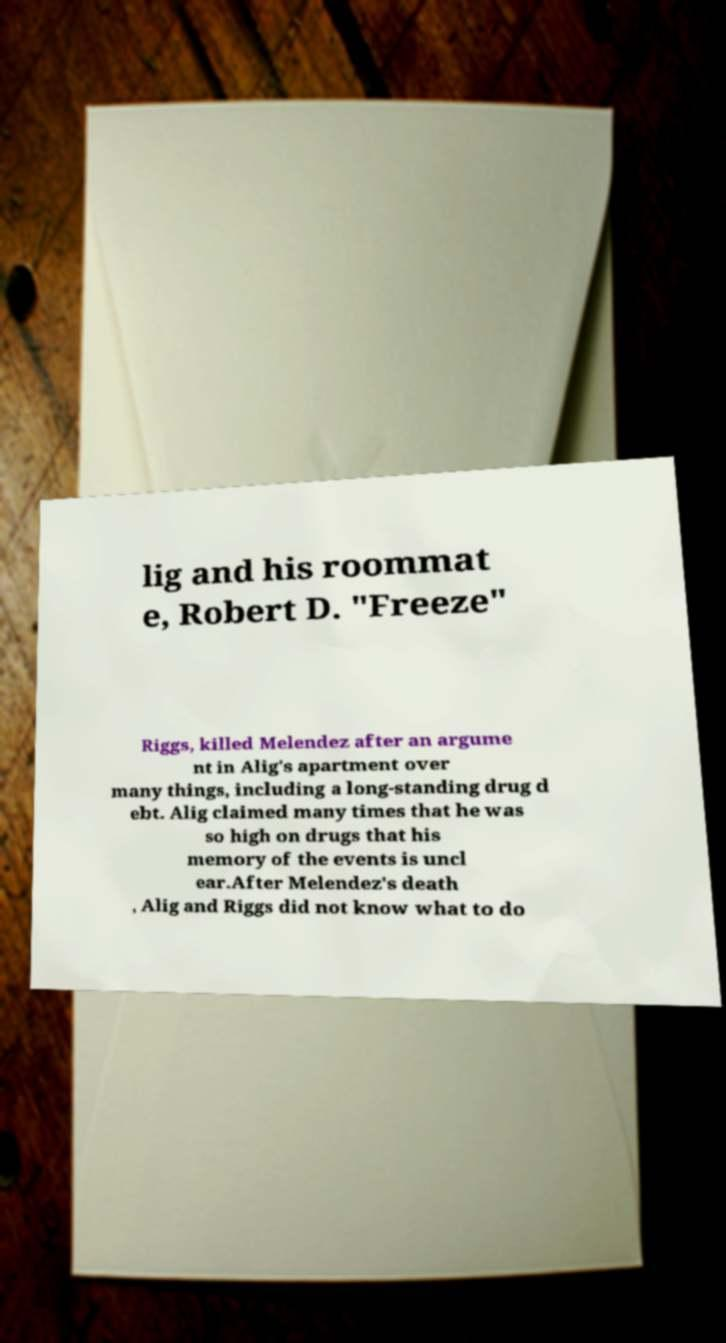There's text embedded in this image that I need extracted. Can you transcribe it verbatim? lig and his roommat e, Robert D. "Freeze" Riggs, killed Melendez after an argume nt in Alig's apartment over many things, including a long-standing drug d ebt. Alig claimed many times that he was so high on drugs that his memory of the events is uncl ear.After Melendez's death , Alig and Riggs did not know what to do 